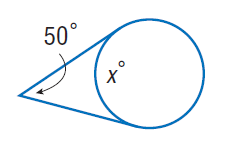Answer the mathemtical geometry problem and directly provide the correct option letter.
Question: Find x. Assume that any segment that appears to be tangent is tangent.
Choices: A: 50 B: 65 C: 115 D: 130 D 